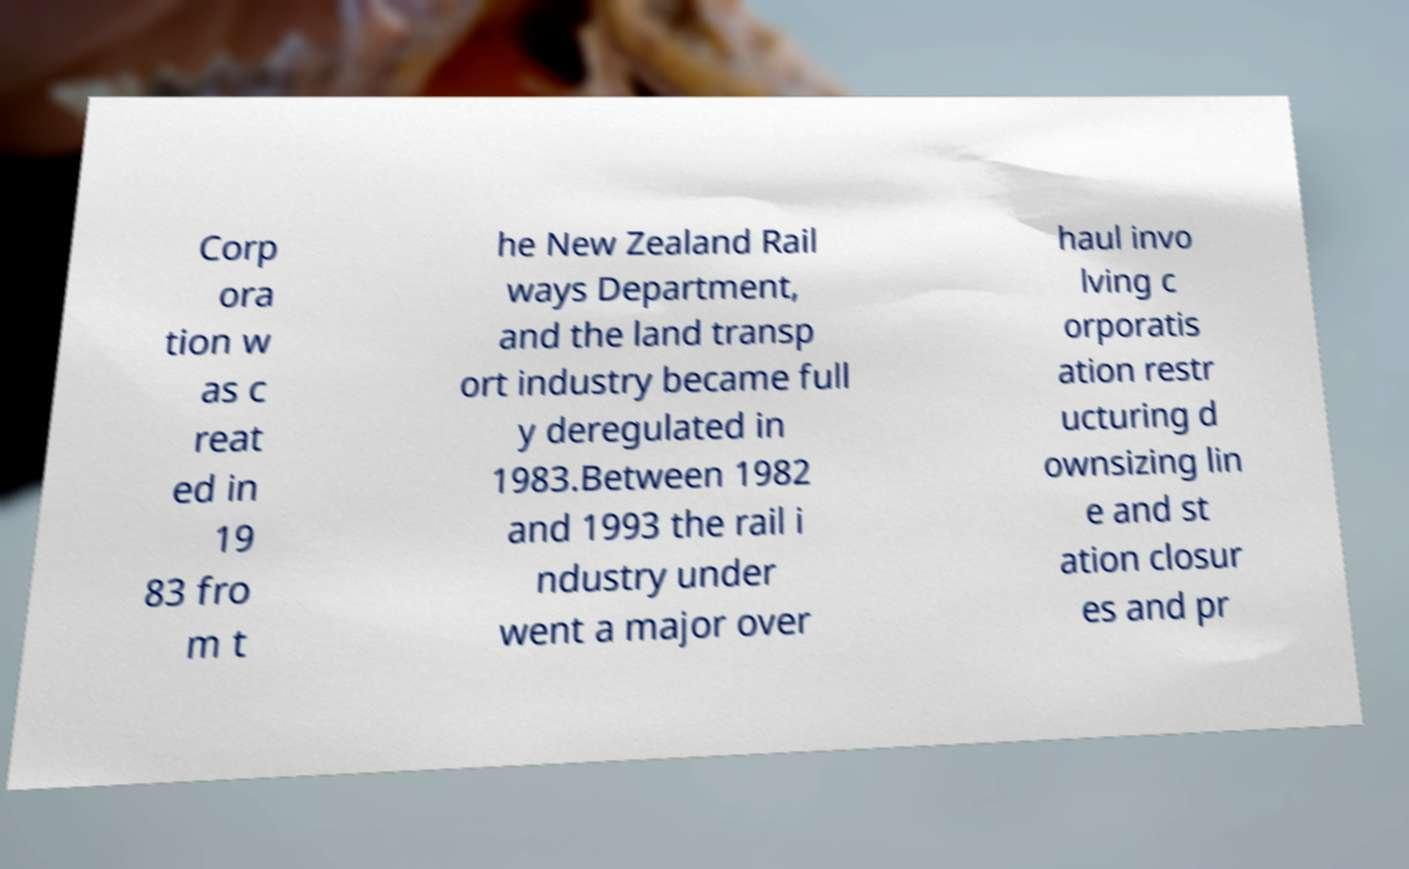Please identify and transcribe the text found in this image. Corp ora tion w as c reat ed in 19 83 fro m t he New Zealand Rail ways Department, and the land transp ort industry became full y deregulated in 1983.Between 1982 and 1993 the rail i ndustry under went a major over haul invo lving c orporatis ation restr ucturing d ownsizing lin e and st ation closur es and pr 